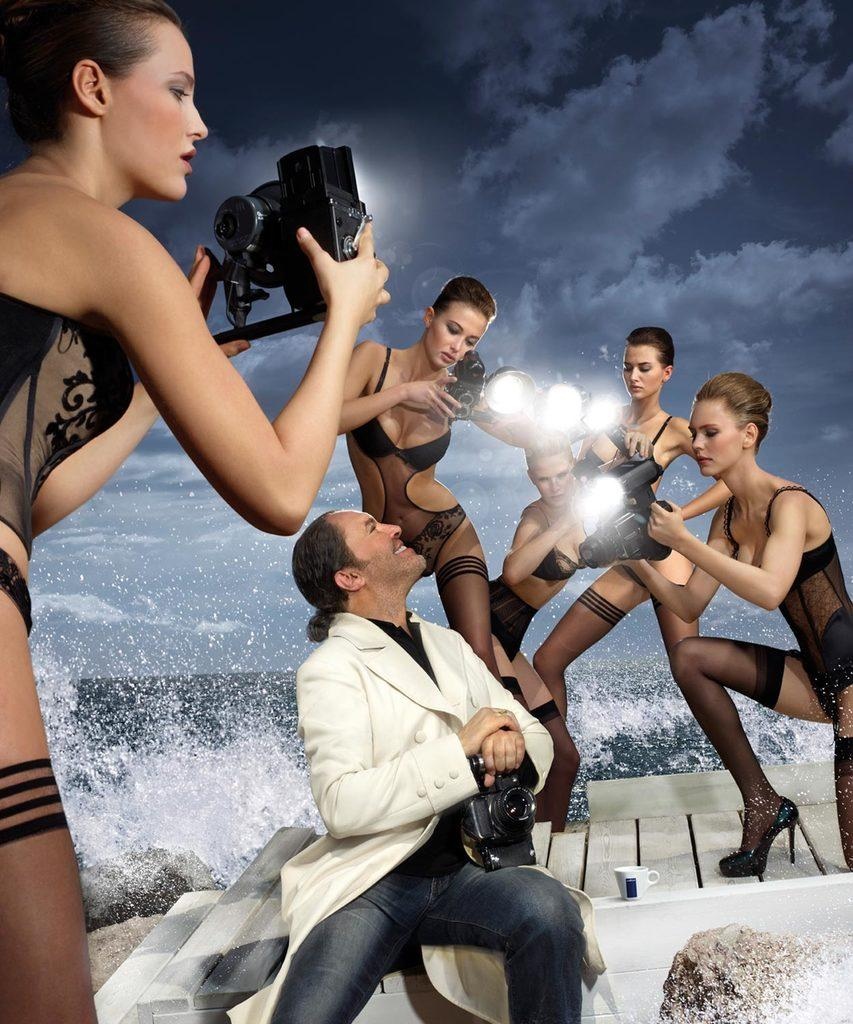What are the women in the image holding? The women in the image are holding lights. What is the man in the image doing? The man is seated on the stairs and holding a camera. What can be seen in the background of the image? There is water visible in the image, and there are clouds in the sky. What is the position of the tooth in the image? There is no tooth present in the image. What degree of difficulty is the man experiencing while holding the camera in the image? The image does not provide information about the man's experience or the difficulty of holding the camera. 